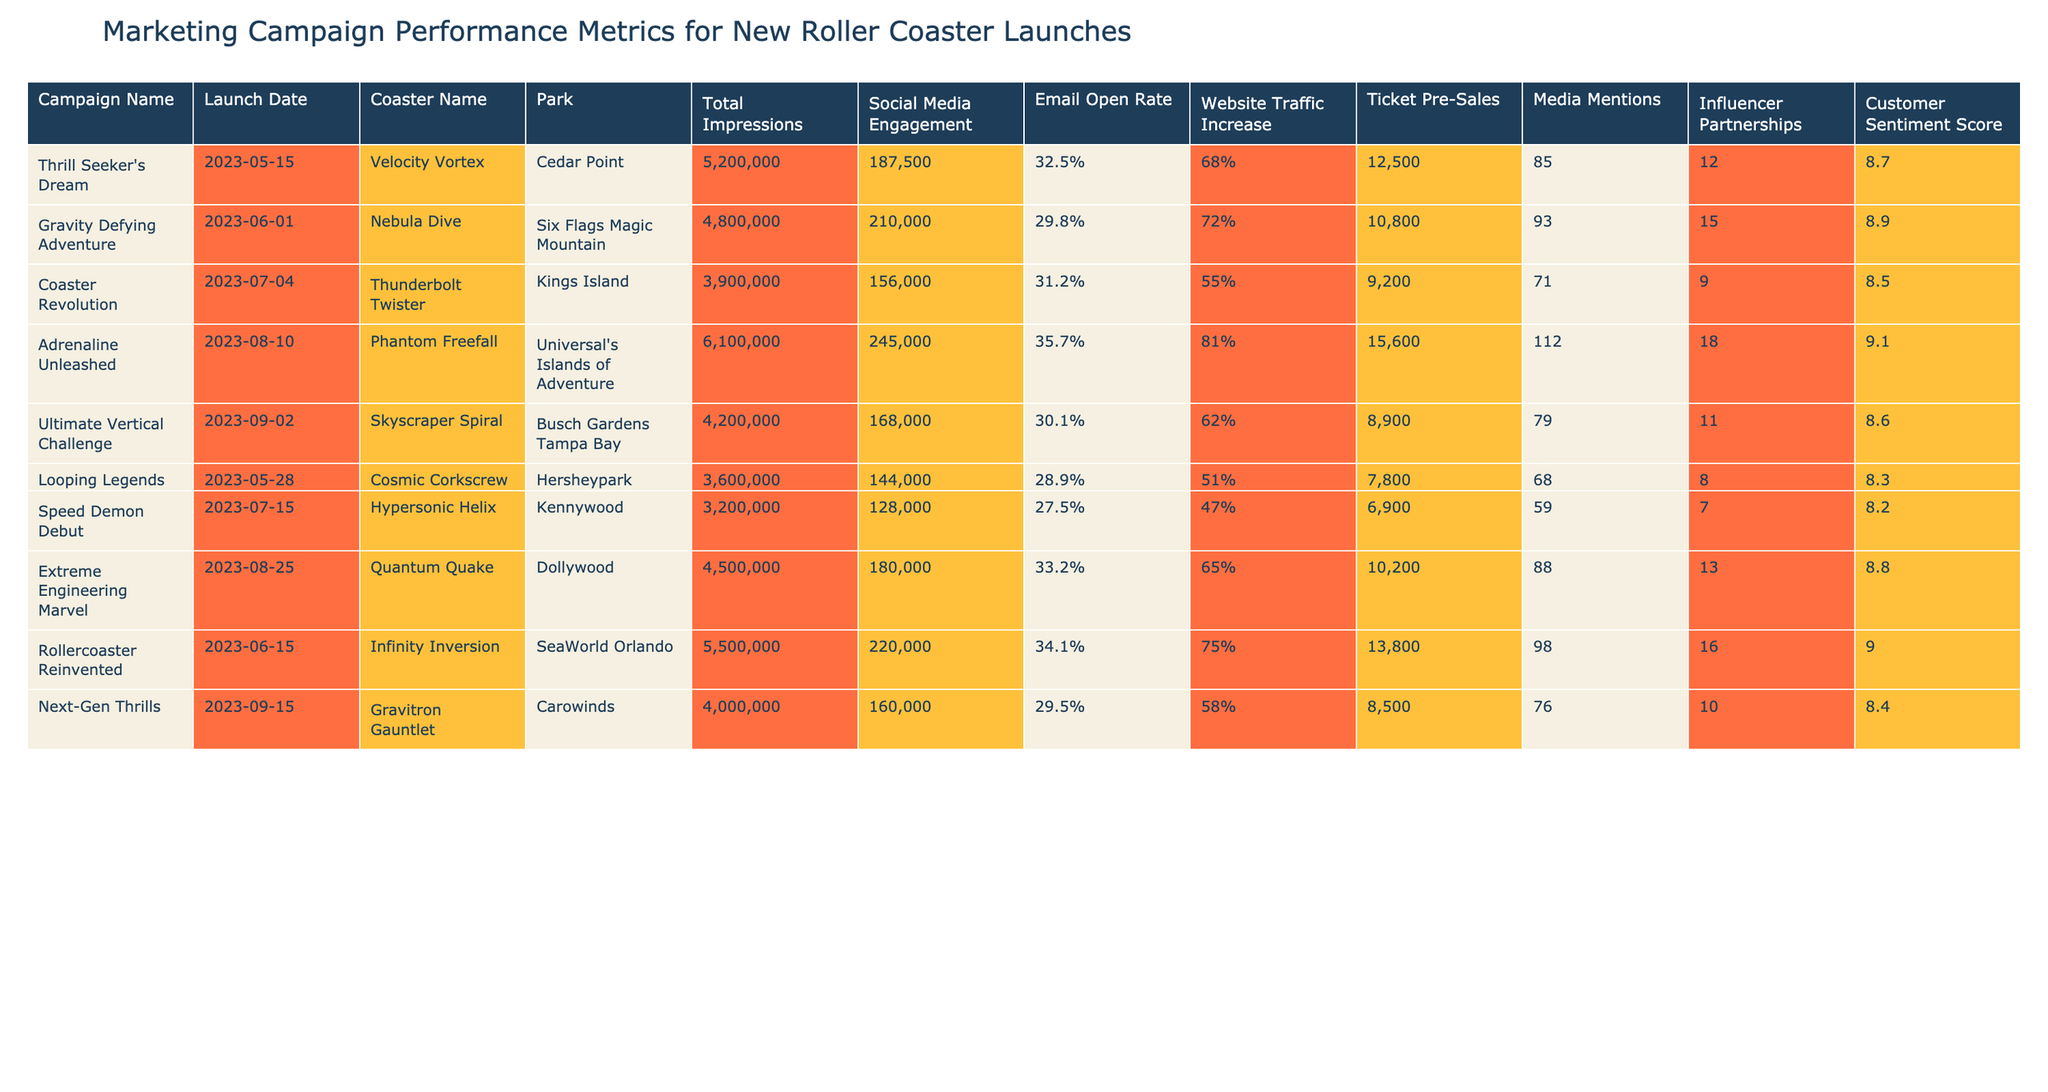What's the highest ticket pre-sales amount recorded in the table? The highest ticket pre-sales can be found by scanning through the "Ticket Pre-Sales" column. The values are 12,500, 10,800, 9,200, 15,600, 8,900, 7,800, 6,900, 10,200, 13,800, and 8,500, with 15,600 being the largest.
Answer: 15,600 Which campaign had the highest social media engagement? To find the highest social media engagement, we look at the "Social Media Engagement" column. The values are 187,500, 210,000, 156,000, 245,000, 168,000, 144,000, 128,000, 180,000, 220,000, and 160,000, with 245,000 being the highest for the "Adrenaline Unleashed" campaign.
Answer: "Adrenaline Unleashed" What is the total number of influencer partnerships across all campaigns? We sum the "Influencer Partnerships" column values: 12 + 15 + 9 + 18 + 11 + 8 + 7 + 13 + 16 + 10 = 119.
Answer: 119 Did any campaign have a customer sentiment score below 8.5? Checking the "Customer Sentiment Score" column, the values are 8.7, 8.9, 8.5, 9.1, 8.6, 8.3, 8.2, 8.8, 9.0, and 8.4. The "Looping Legends" campaign with a score of 8.3 is below 8.5, confirming that there was a campaign with a score below that threshold.
Answer: Yes What is the average email open rate for all campaigns? To calculate the average email open rate, we convert the percentage values into decimals: 0.325, 0.298, 0.312, 0.357, 0.301, 0.289, 0.275, 0.332, 0.341, and 0.295. The sum is 3.185, and since there are 10 campaigns, we divide by 10 to get an average of 0.3185, which translates to 31.85%.
Answer: 31.85% Which park had the highest total impressions for a single campaign? Reviewing the "Total Impressions" column, the values are 5,200,000, 4,800,000, 3,900,000, 6,100,000, 4,200,000, 3,600,000, 3,200,000, 4,500,000, 5,500,000, and 4,000,000, the highest is 6,100,000 from Universal's Islands of Adventure.
Answer: Universal's Islands of Adventure How many campaigns recorded more than 150,000 social media engagements? We need to count the campaigns in the "Social Media Engagement" column that exceed 150,000. The values above are 187,500, 210,000, and 245,000, which means there are 3 campaigns that meet this criterion.
Answer: 3 Which campaign had the lowest increase in website traffic? The website traffic increase values are 68%, 72%, 55%, 81%, 62%, 51%, 47%, 65%, 75%, and 58%. The lowest percentage is 47%, corresponding to the "Speed Demon Debut" campaign.
Answer: "Speed Demon Debut" What is the difference in ticket pre-sales between the highest and lowest campaigns? The highest ticket pre-sales is 15,600, and the lowest is 6,900 according to the "Ticket Pre-Sales" column. The difference is calculated as 15,600 - 6,900 = 8,700.
Answer: 8,700 Is there a campaign associated with Kings Island that had over 200,000 media mentions? Looking at the "Media Mentions" column, the values for all campaigns are: 85, 93, 71, 112, 79, 68, 59, 88, 98, and 76. None of these values exceed 200,000, supporting a negative answer to the question.
Answer: No 